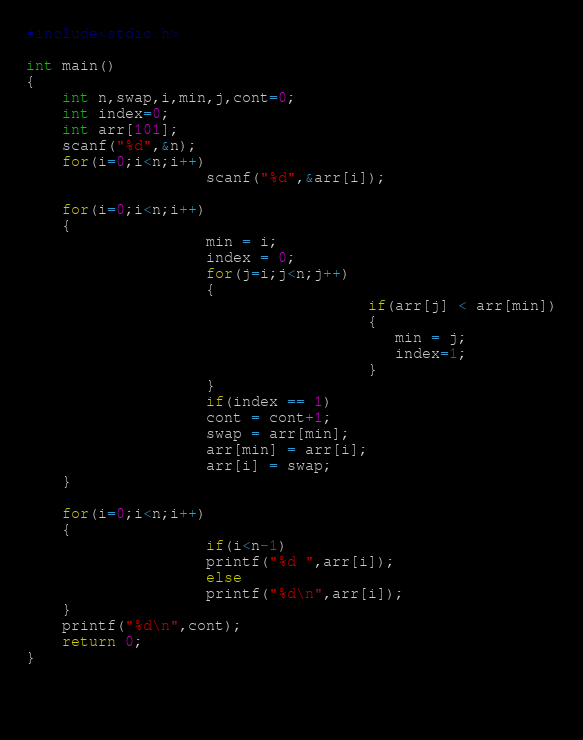<code> <loc_0><loc_0><loc_500><loc_500><_C_>#include<stdio.h>

int main()
{
    int n,swap,i,min,j,cont=0;
    int index=0;
    int arr[101];
    scanf("%d",&n);
    for(i=0;i<n;i++)
                    scanf("%d",&arr[i]);
    
    for(i=0;i<n;i++)
    {
                    min = i;
                    index = 0;
                    for(j=i;j<n;j++)
                    {
                                      if(arr[j] < arr[min])
                                      {
                                         min = j;  
                                         index=1;     
                                      }
                    }
                    if(index == 1)
                    cont = cont+1;
                    swap = arr[min];
                    arr[min] = arr[i];
                    arr[i] = swap;
    }
                    
    for(i=0;i<n;i++)
    {
                    if(i<n-1)
                    printf("%d ",arr[i]);
                    else
                    printf("%d\n",arr[i]);
    }
    printf("%d\n",cont);
    return 0;
}
    
    
    </code> 